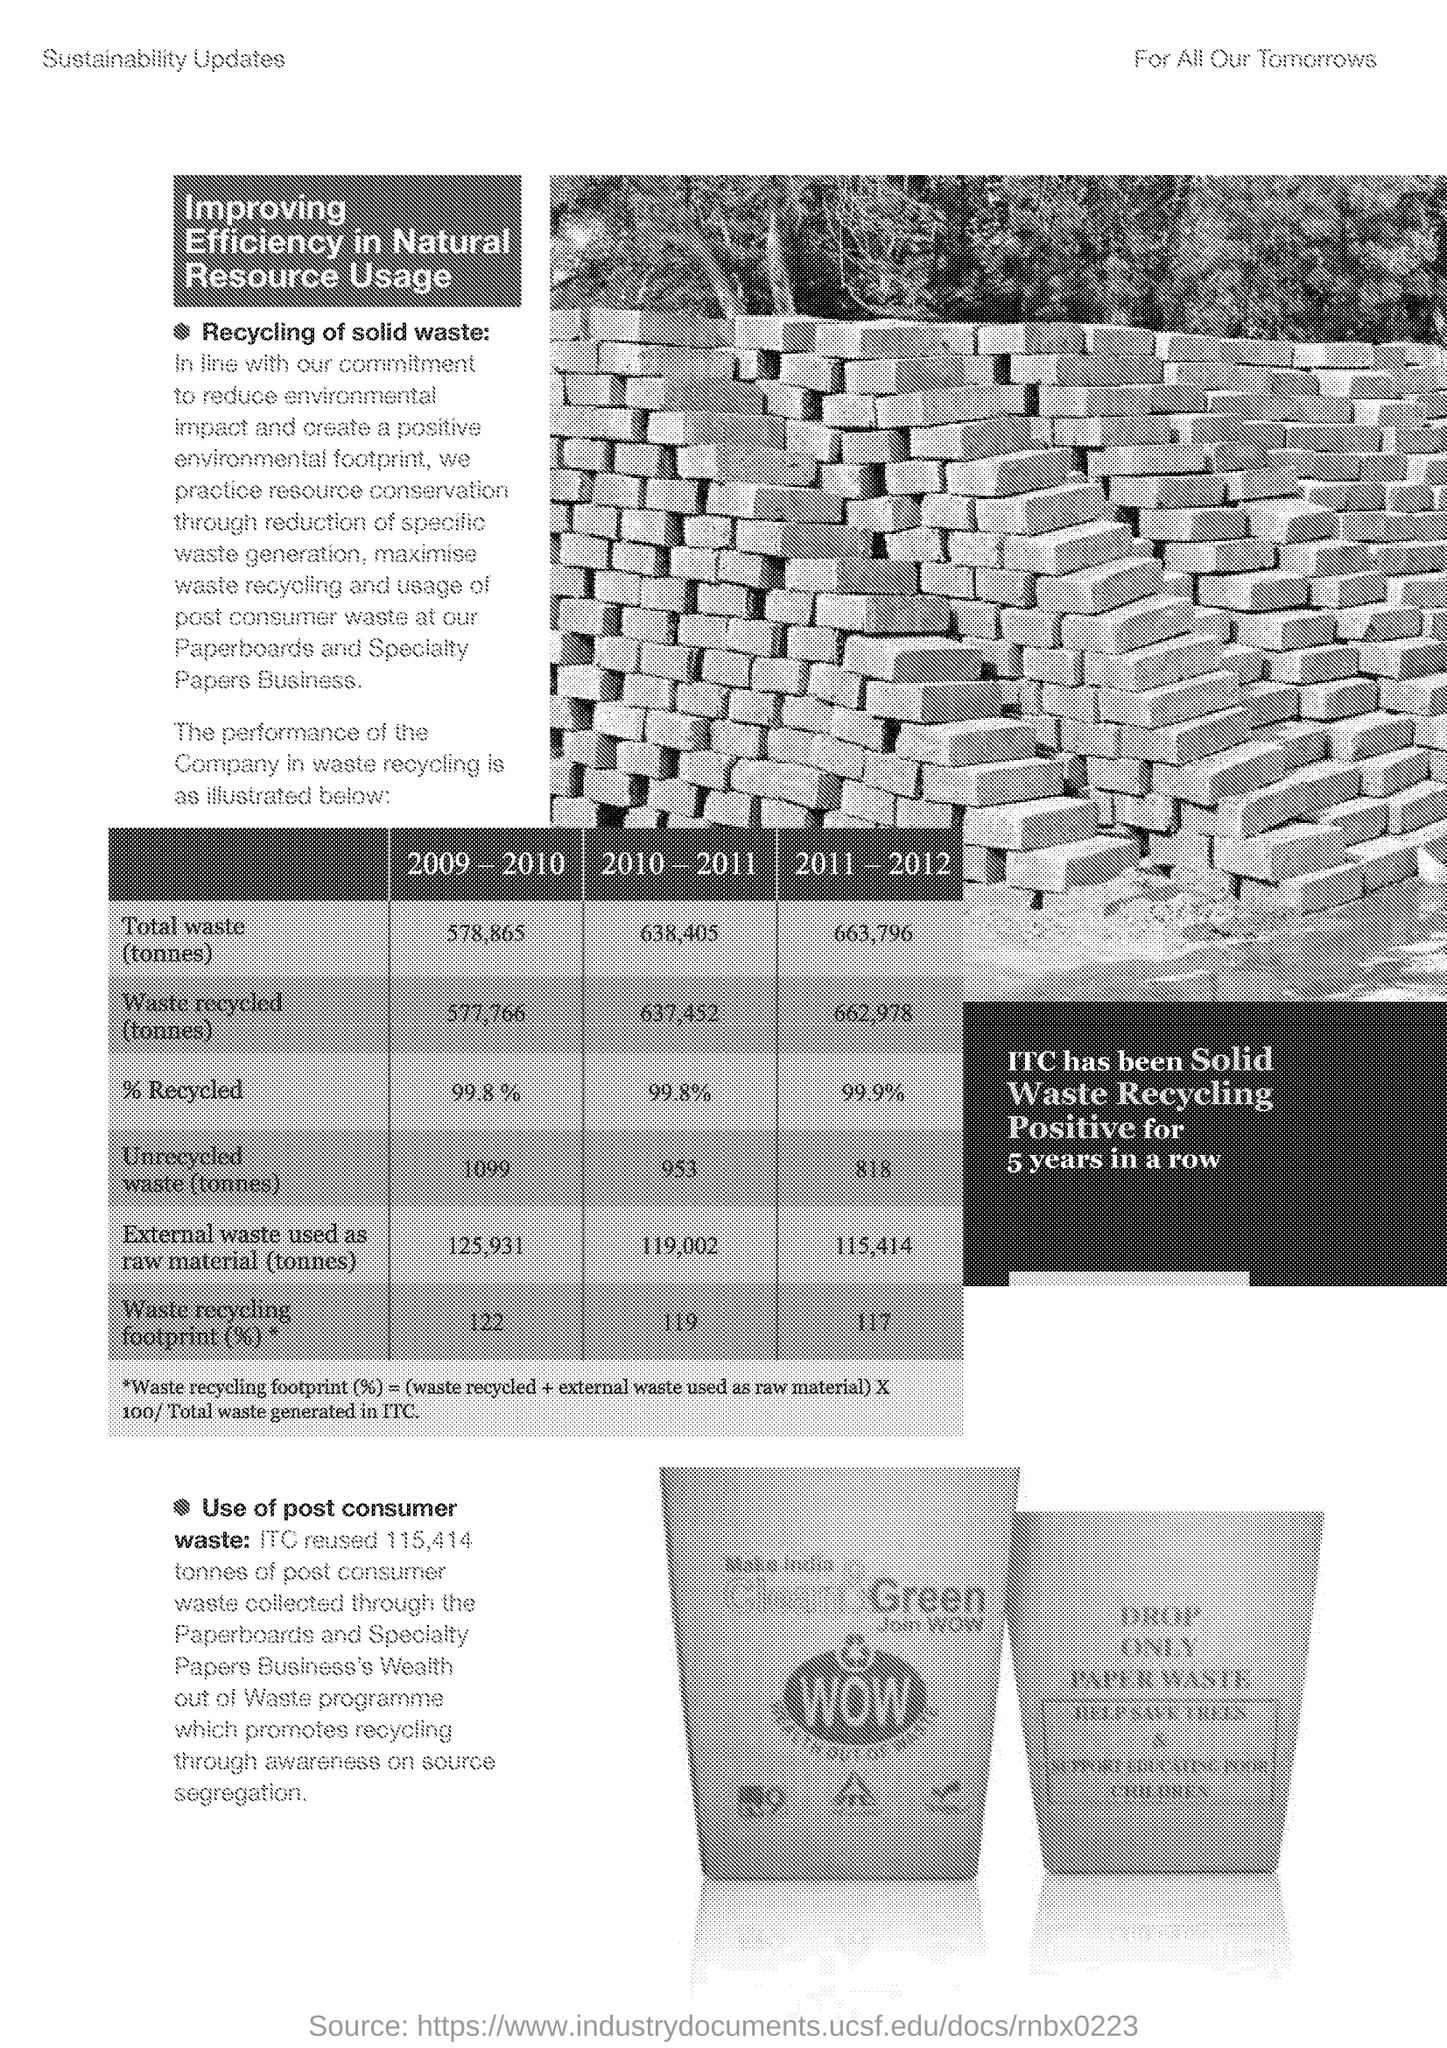Point out several critical features in this image. I'm sorry, but the information you provided is not complete or structured. In order to provide an accurate response, I would need more information such as the context of the question, the source of the information, and the specific data you are referring to. Please provide more details so that I can better understand your question and provide a helpful response. 